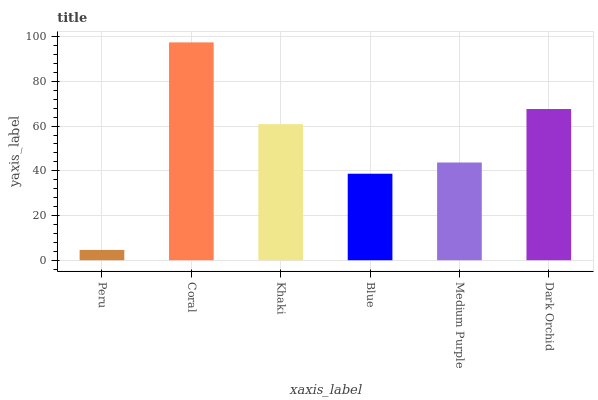Is Khaki the minimum?
Answer yes or no. No. Is Khaki the maximum?
Answer yes or no. No. Is Coral greater than Khaki?
Answer yes or no. Yes. Is Khaki less than Coral?
Answer yes or no. Yes. Is Khaki greater than Coral?
Answer yes or no. No. Is Coral less than Khaki?
Answer yes or no. No. Is Khaki the high median?
Answer yes or no. Yes. Is Medium Purple the low median?
Answer yes or no. Yes. Is Dark Orchid the high median?
Answer yes or no. No. Is Dark Orchid the low median?
Answer yes or no. No. 